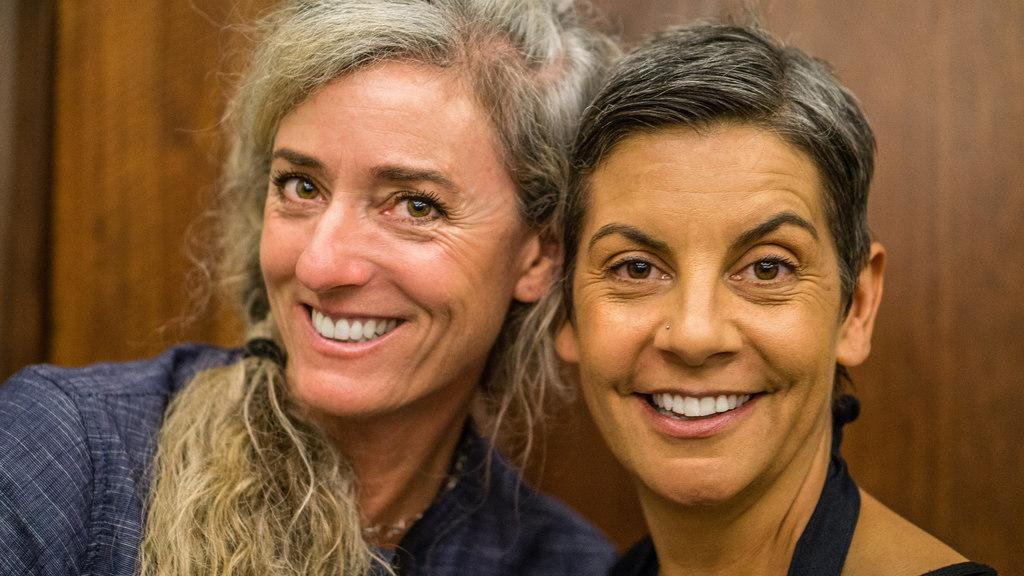Who is present in the image? There are women in the image. What expression do the women have? The women are smiling. Can you see a rabbit in the image? There is no rabbit present in the image. What type of expansion is taking place in the image? There is no expansion mentioned or visible in the image. 